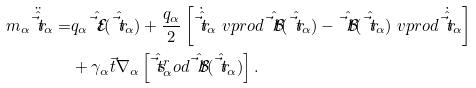Convert formula to latex. <formula><loc_0><loc_0><loc_500><loc_500>m _ { \alpha } \ddot { \hat { \vec { t } { r } } } _ { \alpha } = & q _ { \alpha } \hat { \vec { t } { \mathcal { E } } } ( \hat { \vec { t } { r } } _ { \alpha } ) + \frac { q _ { \alpha } } { 2 } \left [ \dot { \hat { \vec { t } { r } } } _ { \alpha } \ v p r o d \hat { \vec { t } { \mathcal { B } } } ( \hat { \vec { t } { r } } _ { \alpha } ) - \hat { \vec { t } { \mathcal { B } } } ( \hat { \vec { t } { r } } _ { \alpha } ) \ v p r o d \dot { \hat { \vec { t } { r } } } _ { \alpha } \right ] \\ & + \gamma _ { \alpha } \vec { t } { \nabla } _ { \alpha } \left [ \hat { \vec { t } { s } } _ { \alpha } ^ { r } o d \hat { \vec { t } { \mathcal { B } } } ( \hat { \vec { t } { r } } _ { \alpha } ) \right ] .</formula> 